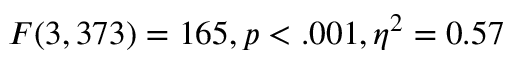<formula> <loc_0><loc_0><loc_500><loc_500>F ( 3 , 3 7 3 ) = 1 6 5 , p < . 0 0 1 , \eta ^ { 2 } = 0 . 5 7</formula> 